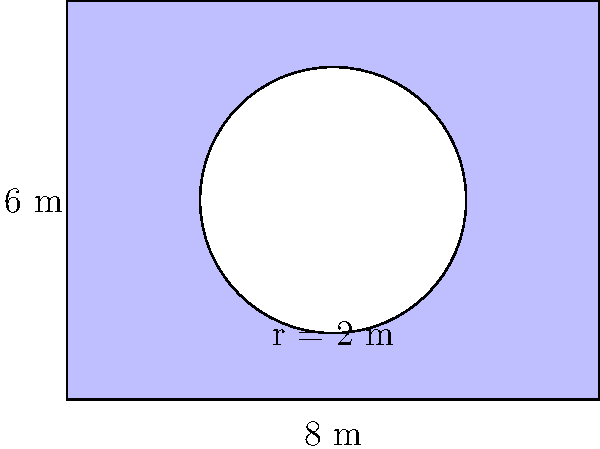You are designing a mural for the town square that showcases Culkin's history. The mural is rectangular with a circular cutout in the center for a clock. If the mural is 8 meters wide and 6 meters tall, with a circular cutout of radius 2 meters at its center, what is the total area of the mural in square meters? To find the total area of the mural, we need to:

1. Calculate the area of the rectangular mural:
   $A_{rectangle} = width \times height = 8 \text{ m} \times 6 \text{ m} = 48 \text{ m}^2$

2. Calculate the area of the circular cutout:
   $A_{circle} = \pi r^2 = \pi \times (2 \text{ m})^2 = 4\pi \text{ m}^2$

3. Subtract the area of the circular cutout from the rectangular area:
   $A_{total} = A_{rectangle} - A_{circle} = 48 \text{ m}^2 - 4\pi \text{ m}^2$

4. Simplify:
   $A_{total} = 48 - 4\pi \approx 35.44 \text{ m}^2$

Therefore, the total area of the mural is approximately 35.44 square meters.
Answer: $48 - 4\pi \text{ m}^2$ or approximately 35.44 m² 